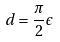<formula> <loc_0><loc_0><loc_500><loc_500>d = \frac { \pi } { 2 } \epsilon</formula> 